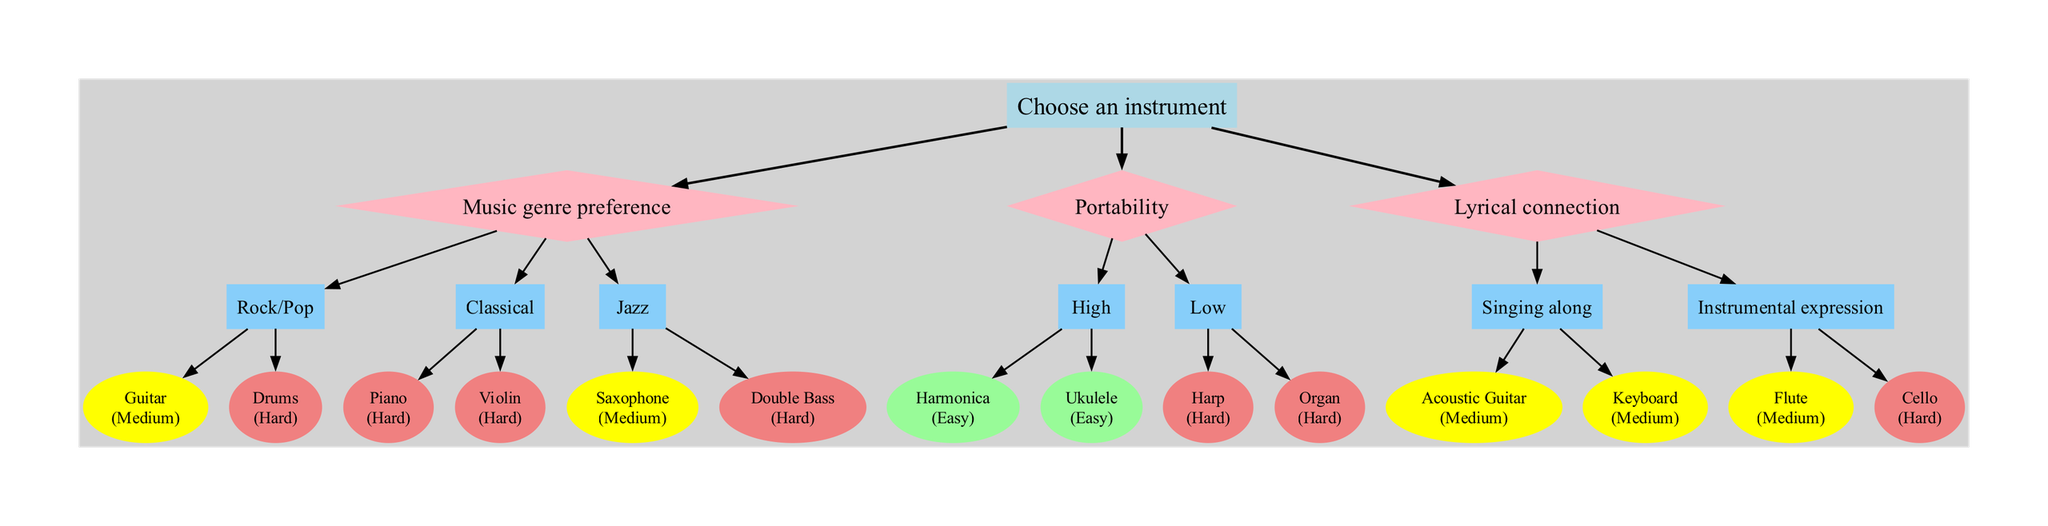What is the root node of the decision tree? The root node represents the starting point of the decision-making process, which is "Choose an instrument."
Answer: Choose an instrument How many main categories are there in the diagram? There are three main categories stemming from the root node: Music genre preference, Portability, and Lyrical connection.
Answer: 3 What is the difficulty level of playing the piano? The piano is classified as having a difficulty level of "Hard," specified in the diagram.
Answer: Hard Which instrument is easy to carry and also easy to learn? The diagram indicates two instruments that fit this description: "Harmonica" and "Ukulele," both listed under the portability category with high portability and easy difficulty.
Answer: Harmonica, Ukulele If someone prefers classical music, which instruments are available for them? The instruments offered for someone with a preference for classical music are "Piano" and "Violin," both listed under the classical category.
Answer: Piano, Violin What is the connection between "Singing along" and the instruments listed under it? "Singing along" leads to two instruments: "Acoustic Guitar" and "Keyboard," both of which are capable of supporting a vocal performance and have a "Medium" difficulty level.
Answer: Acoustic Guitar, Keyboard Which instrument has the highest difficulty level listed in the diagram? The instruments with the highest difficulty in the diagram are "Piano," "Violin," "Double Bass," and "Cello," all categorized as having "Hard" difficulty.
Answer: Piano, Violin, Double Bass, Cello What type of instrument is categorized under a low portability level? The instruments categorized under low portability are "Harp" and "Organ," both noted in the portability section of the diagram.
Answer: Harp, Organ Which genre offers a medium level of difficulty in the decision tree? The diagram shows two genres that provide instruments with a medium difficulty level, which are "Rock/Pop" (Guitar) and "Jazz" (Saxophone).
Answer: Rock/Pop, Jazz 